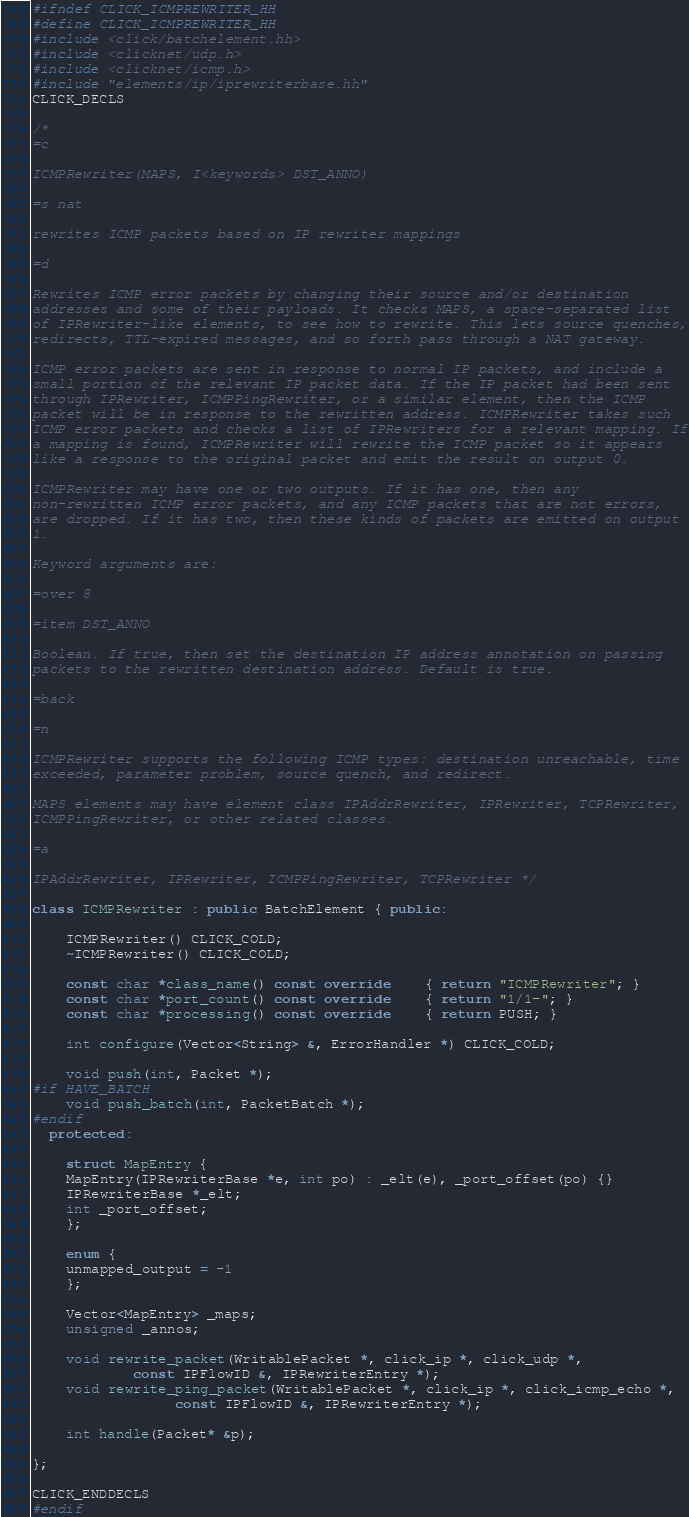Convert code to text. <code><loc_0><loc_0><loc_500><loc_500><_C++_>#ifndef CLICK_ICMPREWRITER_HH
#define CLICK_ICMPREWRITER_HH
#include <click/batchelement.hh>
#include <clicknet/udp.h>
#include <clicknet/icmp.h>
#include "elements/ip/iprewriterbase.hh"
CLICK_DECLS

/*
=c

ICMPRewriter(MAPS, I<keywords> DST_ANNO)

=s nat

rewrites ICMP packets based on IP rewriter mappings

=d

Rewrites ICMP error packets by changing their source and/or destination
addresses and some of their payloads. It checks MAPS, a space-separated list
of IPRewriter-like elements, to see how to rewrite. This lets source quenches,
redirects, TTL-expired messages, and so forth pass through a NAT gateway.

ICMP error packets are sent in response to normal IP packets, and include a
small portion of the relevant IP packet data. If the IP packet had been sent
through IPRewriter, ICMPPingRewriter, or a similar element, then the ICMP
packet will be in response to the rewritten address. ICMPRewriter takes such
ICMP error packets and checks a list of IPRewriters for a relevant mapping. If
a mapping is found, ICMPRewriter will rewrite the ICMP packet so it appears
like a response to the original packet and emit the result on output 0.

ICMPRewriter may have one or two outputs. If it has one, then any
non-rewritten ICMP error packets, and any ICMP packets that are not errors,
are dropped. If it has two, then these kinds of packets are emitted on output
1.

Keyword arguments are:

=over 8

=item DST_ANNO

Boolean. If true, then set the destination IP address annotation on passing
packets to the rewritten destination address. Default is true.

=back

=n

ICMPRewriter supports the following ICMP types: destination unreachable, time
exceeded, parameter problem, source quench, and redirect.

MAPS elements may have element class IPAddrRewriter, IPRewriter, TCPRewriter,
ICMPPingRewriter, or other related classes.

=a

IPAddrRewriter, IPRewriter, ICMPPingRewriter, TCPRewriter */

class ICMPRewriter : public BatchElement { public:

    ICMPRewriter() CLICK_COLD;
    ~ICMPRewriter() CLICK_COLD;

    const char *class_name() const override	{ return "ICMPRewriter"; }
    const char *port_count() const override	{ return "1/1-"; }
    const char *processing() const override	{ return PUSH; }

    int configure(Vector<String> &, ErrorHandler *) CLICK_COLD;

    void push(int, Packet *);
#if HAVE_BATCH
    void push_batch(int, PacketBatch *);
#endif
  protected:

    struct MapEntry {
	MapEntry(IPRewriterBase *e, int po) : _elt(e), _port_offset(po) {}
	IPRewriterBase *_elt;
	int _port_offset;
    };

    enum {
	unmapped_output = -1
    };

    Vector<MapEntry> _maps;
    unsigned _annos;

    void rewrite_packet(WritablePacket *, click_ip *, click_udp *,
			const IPFlowID &, IPRewriterEntry *);
    void rewrite_ping_packet(WritablePacket *, click_ip *, click_icmp_echo *,
			     const IPFlowID &, IPRewriterEntry *);

    int handle(Packet* &p);

};

CLICK_ENDDECLS
#endif
</code> 